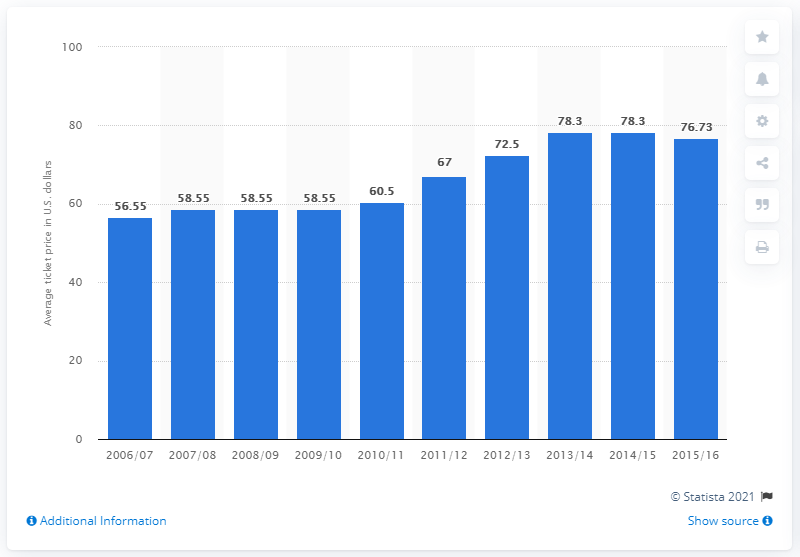Mention a couple of crucial points in this snapshot. In the season of 2015/16, the average ticket price for Miami Heat games changed. The average ticket price for Miami Heat games in the 2006/2007 season was $56.55. 